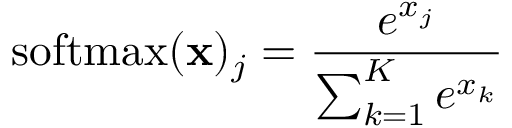<formula> <loc_0><loc_0><loc_500><loc_500>{ s o f t \max } ( x ) _ { j } = { \frac { e ^ { x _ { j } } } { \sum _ { k = 1 } ^ { K } e ^ { x _ { k } } } }</formula> 